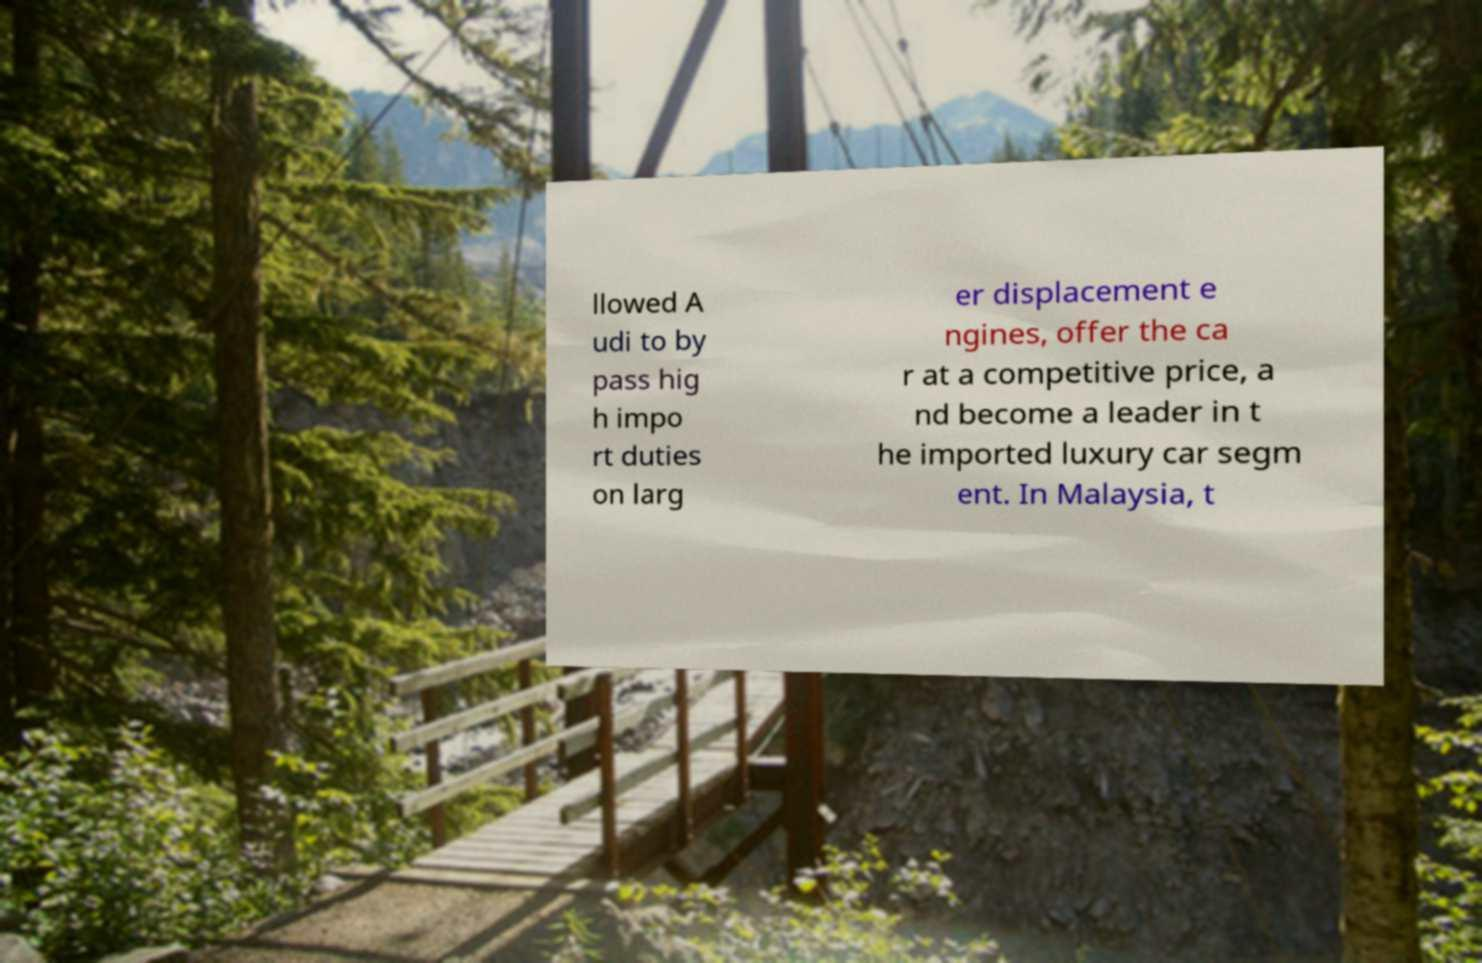Could you extract and type out the text from this image? llowed A udi to by pass hig h impo rt duties on larg er displacement e ngines, offer the ca r at a competitive price, a nd become a leader in t he imported luxury car segm ent. In Malaysia, t 